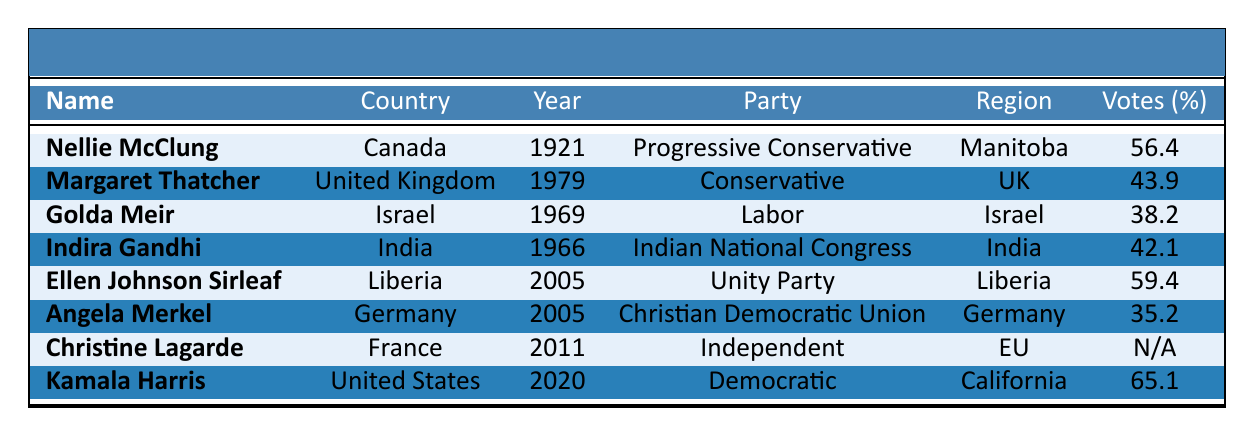What is the name of the only woman elected as a politician in Liberia according to the table? The table lists Ellen Johnson Sirleaf as the only woman elected as a politician in Liberia.
Answer: Ellen Johnson Sirleaf Which country had the woman politician with the highest percentage of votes? According to the data, Kamala Harris from the United States had the highest percentage of votes at 65.1%.
Answer: United States In what year was Indira Gandhi elected as a politician? The table indicates that Indira Gandhi was elected in the year 1966.
Answer: 1966 True or false: All women listed in the table were elected as politicians and not appointed. The table shows that Christine Lagarde was appointed, so not all women were elected.
Answer: False What is the average percentage of votes obtained by the women politicians in Canada according to the table? The only woman politician in Canada is Nellie McClung, who received 56.4%. Since there is only one data point, the average is 56.4%.
Answer: 56.4 Which region had the woman politician with the lowest percentage of votes and what was that percentage? Golda Meir from Israel received the lowest percentage of votes at 38.2%.
Answer: Israel, 38.2% If we compare the election results of Angela Merkel and Kamala Harris, who had a better outcome and by how much? Kamala Harris received 65.1%, while Angela Merkel received 35.2%, making Harris's outcome better by 29.9%.
Answer: Kamala Harris, by 29.9% What percentage of votes did Margaret Thatcher receive in her election? The table indicates that Margaret Thatcher received 43.9% of the votes in her election.
Answer: 43.9% Who was elected as a leader in the year 2005? According to the table, both Ellen Johnson Sirleaf and Angela Merkel were elected in 2005.
Answer: Ellen Johnson Sirleaf and Angela Merkel Which two women politicians led their respective countries to a victory with over 50% of the votes according to the table? The table shows that both Nellie McClung (56.4%) and Ellen Johnson Sirleaf (59.4%) received over 50% of the votes.
Answer: Nellie McClung and Ellen Johnson Sirleaf 